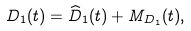Convert formula to latex. <formula><loc_0><loc_0><loc_500><loc_500>D _ { 1 } ( t ) = \widehat { D } _ { 1 } ( t ) + M _ { D _ { 1 } } ( t ) ,</formula> 